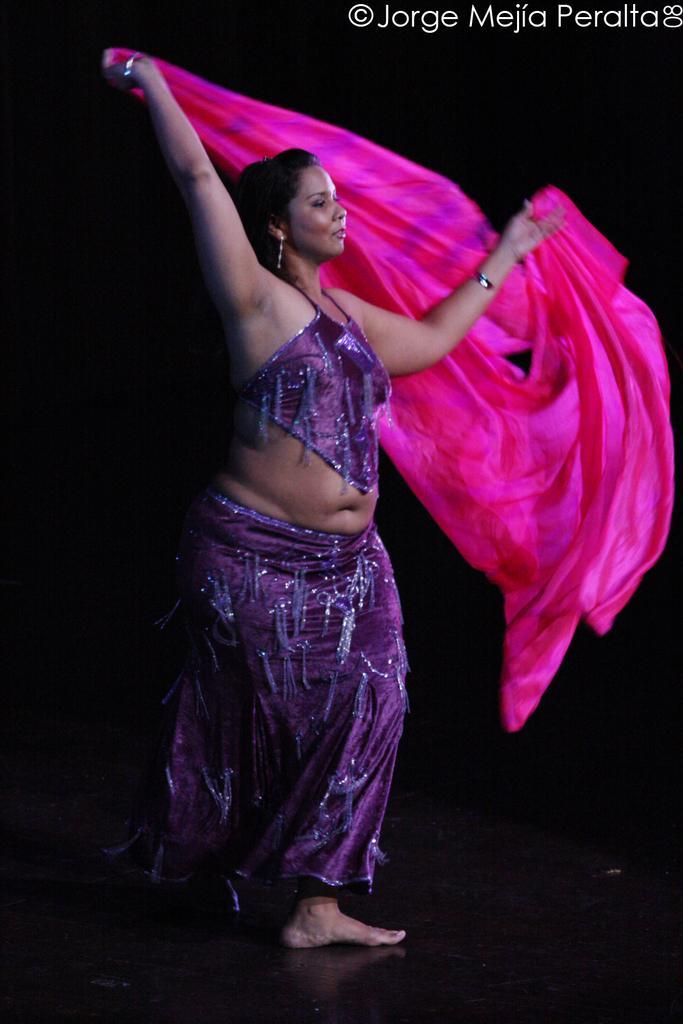Can you describe this image briefly? In the middle of the image there is a lady with violet color dress is standing and holding the pink cloth in her hands. And to the top right corner of the image there is a name. 